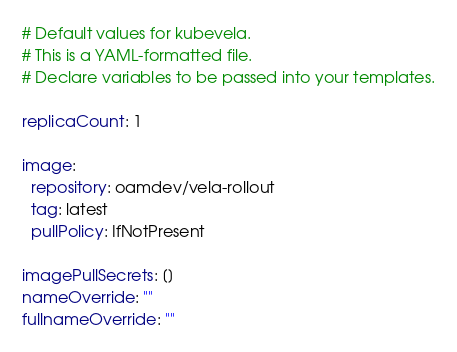Convert code to text. <code><loc_0><loc_0><loc_500><loc_500><_YAML_># Default values for kubevela.
# This is a YAML-formatted file.
# Declare variables to be passed into your templates.

replicaCount: 1

image:
  repository: oamdev/vela-rollout
  tag: latest
  pullPolicy: IfNotPresent

imagePullSecrets: []
nameOverride: ""
fullnameOverride: ""
</code> 